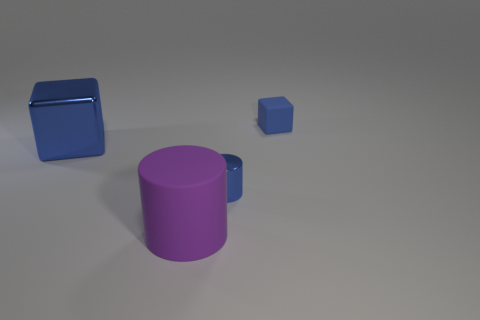What is the texture of the objects and the surface they are on? The objects in the image have a smooth and reflective texture, indicating they are likely made of materials such as polished metal or plastic. The surface on which they rest appears matte and less reflective, which could suggest a contrast in material like painted concrete or some form of matte synthetic material. Based on the texture, what do you think the purpose of these objects might be? Given their simple geometric shapes and the lack of any visible mechanical parts or markings, these objects may be decorative or used for educational purposes, such as teaching geometry. Their reflective textures also suggest that they could be used to demonstrate properties of light, such as reflection and refraction. 